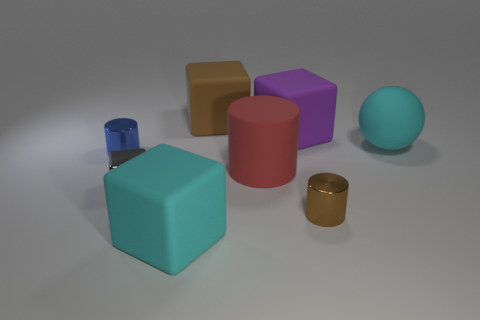Add 1 large metallic cylinders. How many objects exist? 9 Subtract all balls. How many objects are left? 7 Add 3 blue metallic things. How many blue metallic things are left? 4 Add 4 tiny things. How many tiny things exist? 7 Subtract 0 yellow cylinders. How many objects are left? 8 Subtract all big matte blocks. Subtract all large purple matte objects. How many objects are left? 4 